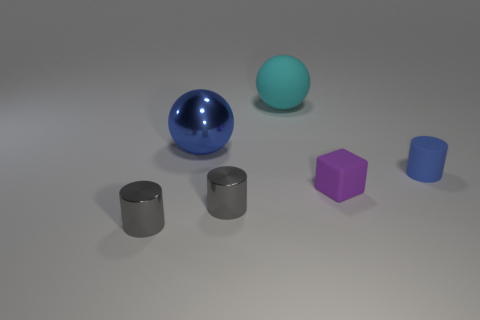Does the matte block have the same size as the blue cylinder?
Offer a very short reply. Yes. There is another small object that is made of the same material as the tiny blue thing; what is its shape?
Your answer should be compact. Cube. How many other objects are the same shape as the small purple rubber thing?
Give a very brief answer. 0. The blue thing that is to the right of the big thing to the right of the large sphere that is in front of the cyan rubber sphere is what shape?
Ensure brevity in your answer.  Cylinder. How many cylinders are large cyan matte things or large blue things?
Ensure brevity in your answer.  0. There is a object behind the large blue metal sphere; are there any tiny things to the right of it?
Your answer should be very brief. Yes. There is a big matte object; does it have the same shape as the metallic object that is behind the tiny blue cylinder?
Make the answer very short. Yes. What number of other things are the same size as the blue matte thing?
Your answer should be compact. 3. What number of brown things are either spheres or big metallic cubes?
Make the answer very short. 0. How many things are both in front of the big cyan sphere and behind the blue cylinder?
Your response must be concise. 1. 